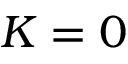Convert formula to latex. <formula><loc_0><loc_0><loc_500><loc_500>K = 0</formula> 